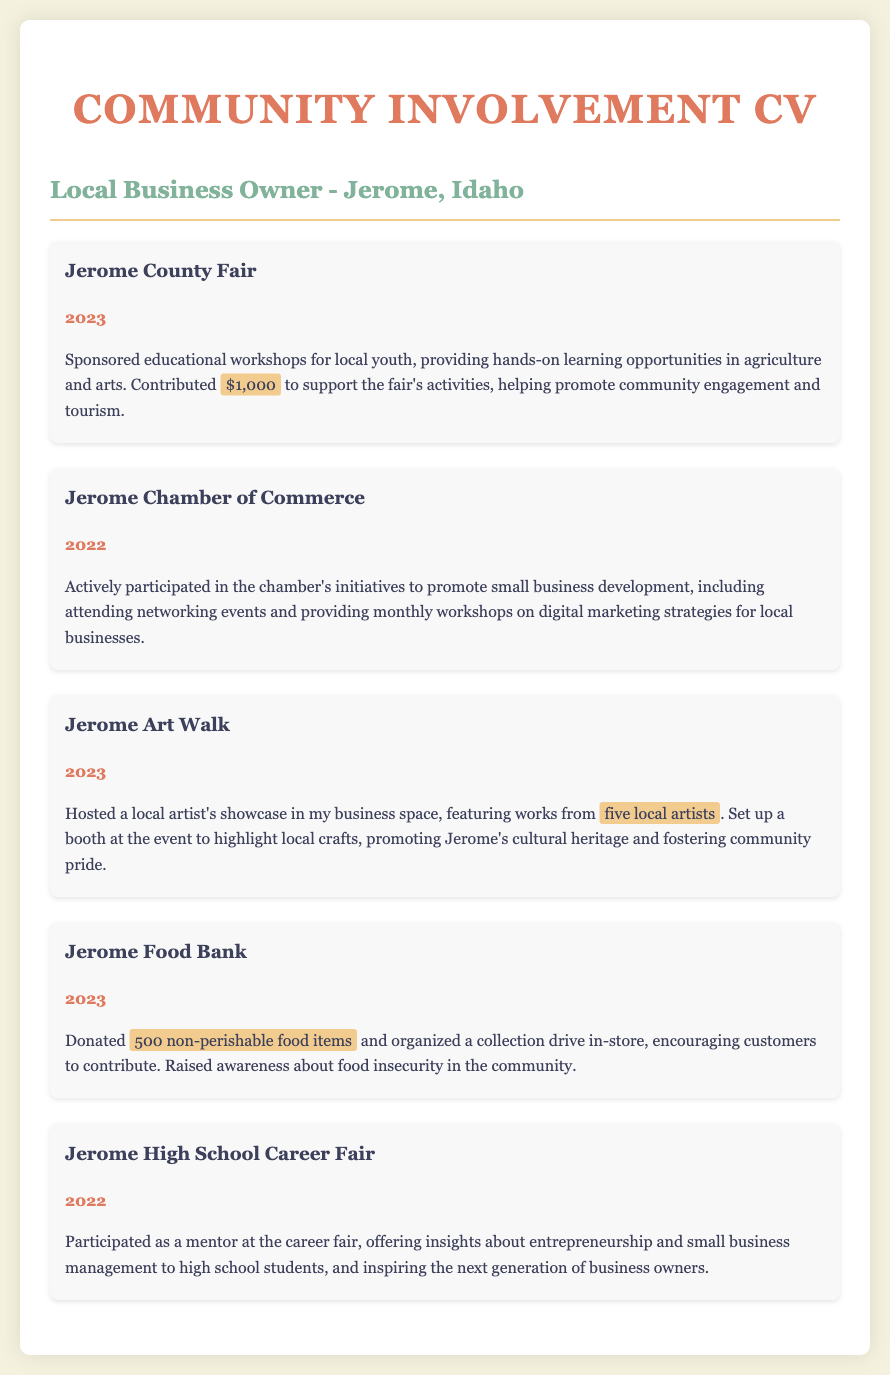what year did you sponsor the Jerome County Fair? The document specifies the year of sponsorship, which is 2023.
Answer: 2023 how much did you contribute to the Jerome County Fair? The document states that the contribution amount was $1,000.
Answer: $1,000 how many local artists were featured at the Jerome Art Walk? The document mentions that five local artists were showcased at the event.
Answer: five local artists what type of drive did you organize for the Jerome Food Bank? The document indicates that a collection drive was organized in-store for food donations.
Answer: collection drive in which event did you participate as a mentor? The document specifies the event where mentorship was provided, which is the Jerome High School Career Fair.
Answer: Jerome High School Career Fair what initiatives were you involved with at the Jerome Chamber of Commerce? The document outlines participation in promoting small business development initiatives and attending networking events.
Answer: small business development initiatives how many non-perishable food items were donated to the Jerome Food Bank? The document states that 500 non-perishable food items were donated.
Answer: 500 non-perishable food items what year did you participate in the Jerome High School Career Fair? The document states the participation year as 2022.
Answer: 2022 how did you promote local crafts during the Jerome Art Walk? The document mentions setting up a booth to highlight local crafts.
Answer: setting up a booth 